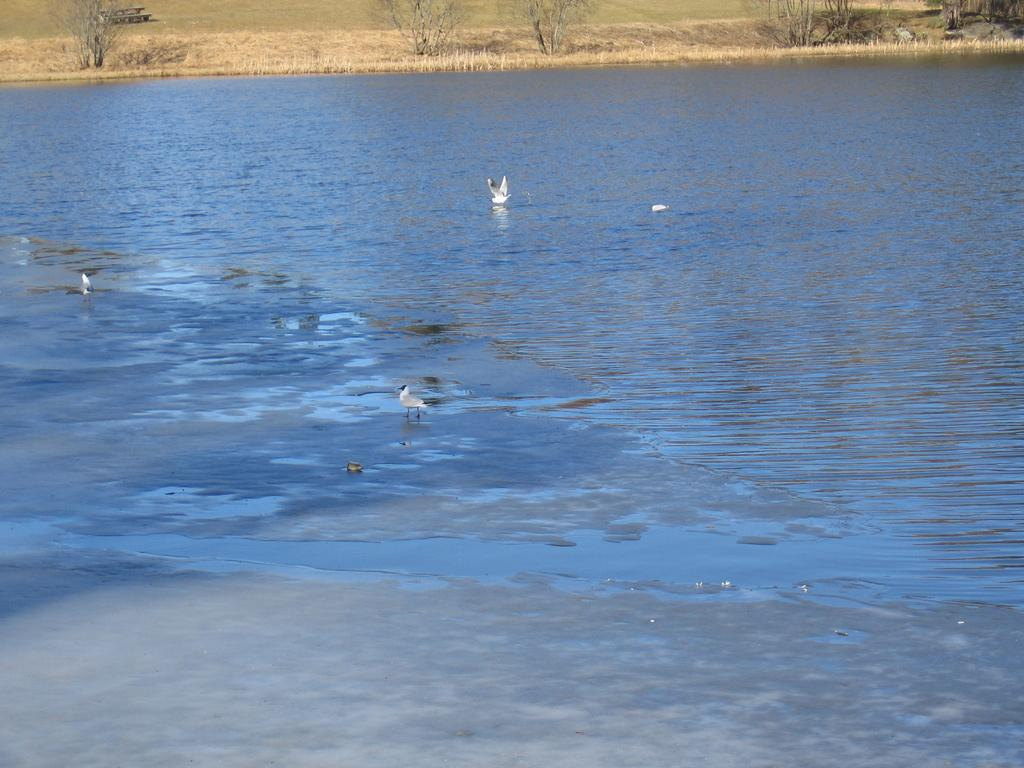What is one of the natural elements present in the image? There is water in the image. What type of vegetation can be seen in the image? There is grass in the image. What type of animals are present in the image? There are white-colored birds in the image. What type of fruit is being cut with a knife in the image? There is no fruit or knife present in the image. 